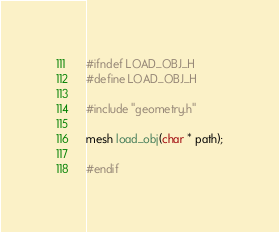<code> <loc_0><loc_0><loc_500><loc_500><_C_>#ifndef LOAD_OBJ_H
#define LOAD_OBJ_H

#include "geometry.h"

mesh load_obj(char * path);

#endif</code> 